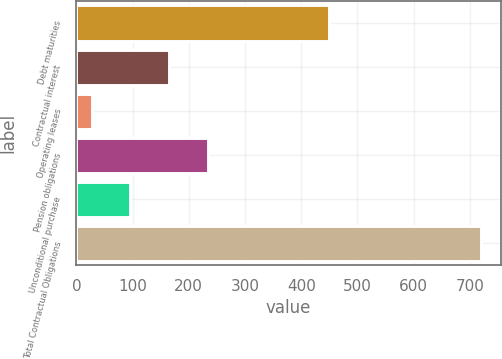Convert chart. <chart><loc_0><loc_0><loc_500><loc_500><bar_chart><fcel>Debt maturities<fcel>Contractual interest<fcel>Operating leases<fcel>Pension obligations<fcel>Unconditional purchase<fcel>Total Contractual Obligations<nl><fcel>449<fcel>165.4<fcel>27<fcel>234.6<fcel>96.2<fcel>719<nl></chart> 